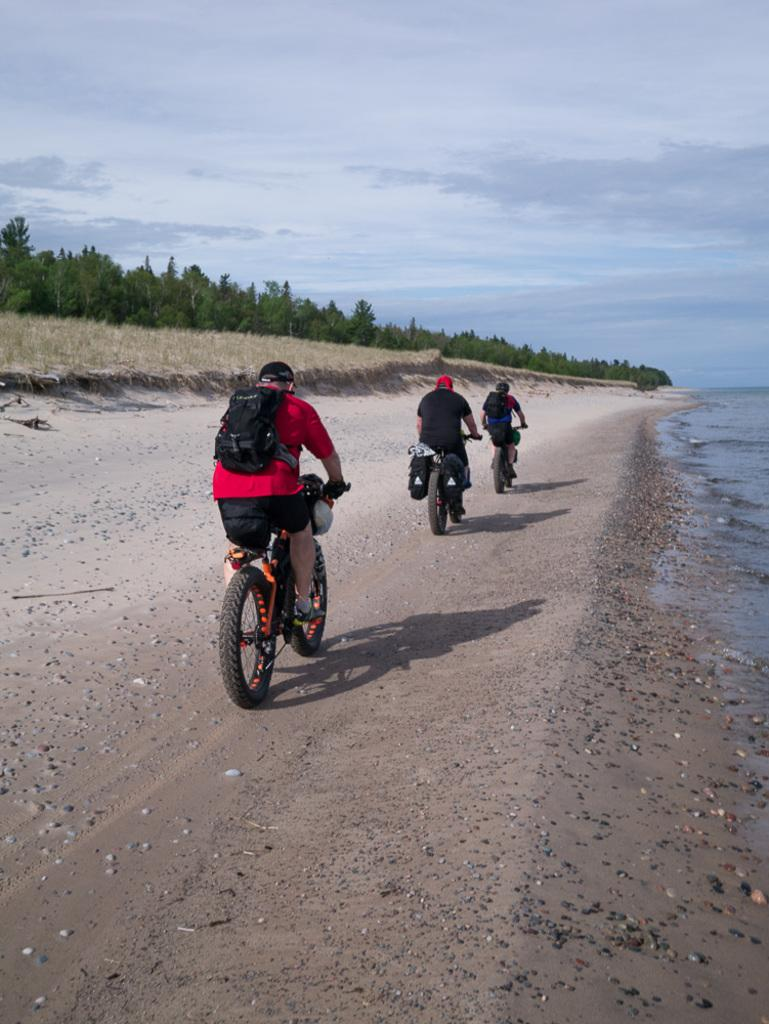What are the three persons in the image doing? The three persons are riding bicycles in the image. What can be seen beneath the persons riding bicycles? The ground is visible in the image. What is present on the right side of the image? There is water on the right side of the image. What type of vegetation is on the left side of the image? There are trees on the left side of the image. What is visible at the top of the image? The sky is visible at the top of the image. What type of cherry is being used as a handlebar grip on one of the bicycles in the image? There is no cherry present in the image, and none of the bicycles have cherry handlebar grips. 